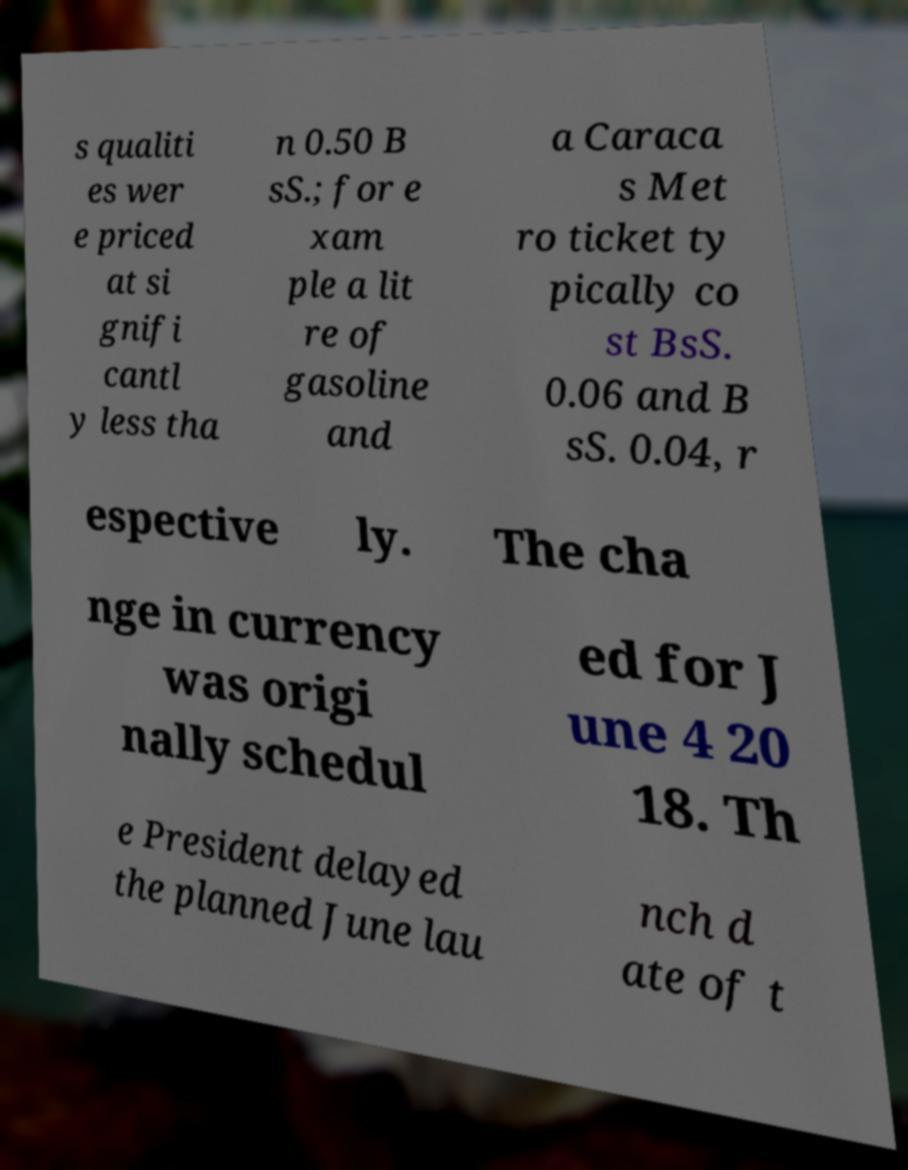There's text embedded in this image that I need extracted. Can you transcribe it verbatim? s qualiti es wer e priced at si gnifi cantl y less tha n 0.50 B sS.; for e xam ple a lit re of gasoline and a Caraca s Met ro ticket ty pically co st BsS. 0.06 and B sS. 0.04, r espective ly. The cha nge in currency was origi nally schedul ed for J une 4 20 18. Th e President delayed the planned June lau nch d ate of t 